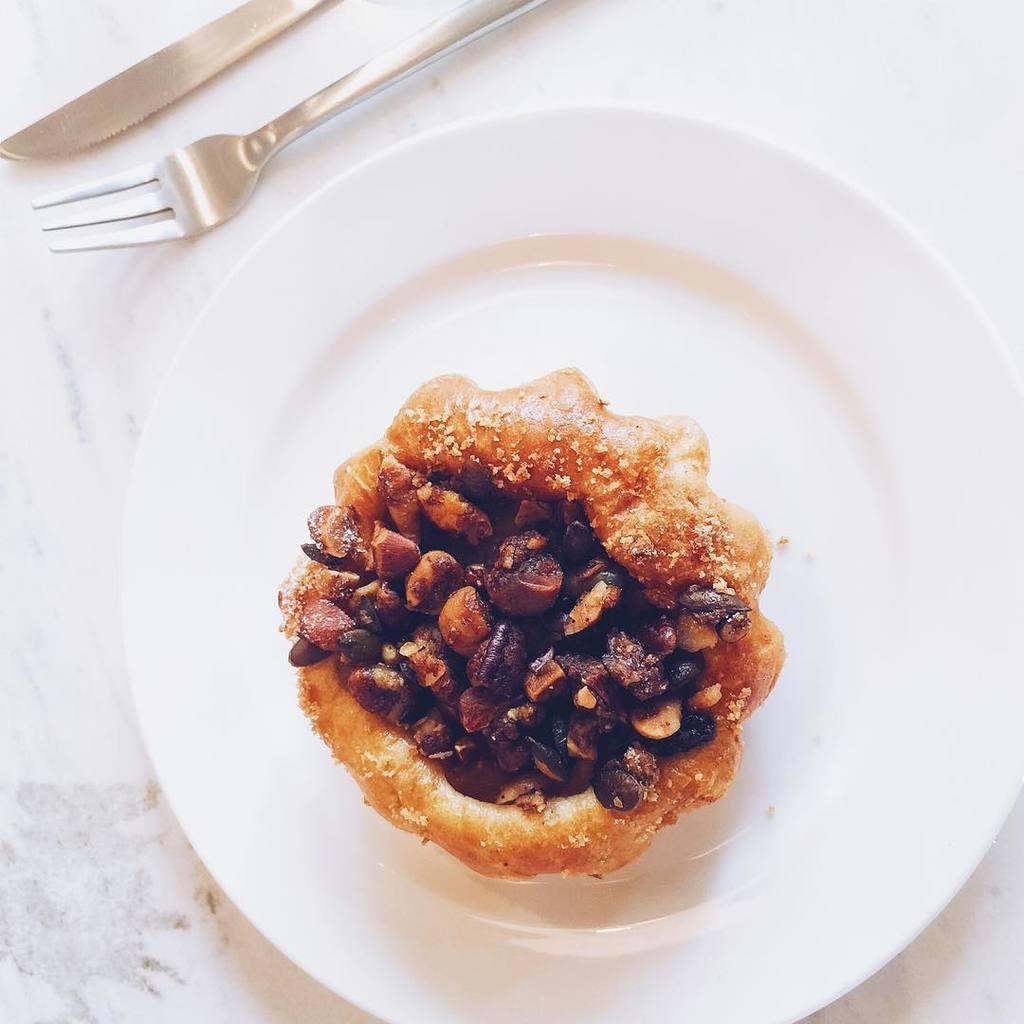Could you give a brief overview of what you see in this image? In this image, we can see food on the white plate. This white plate is placed on the white surface. Top of the image, we can see a knife and fork. 